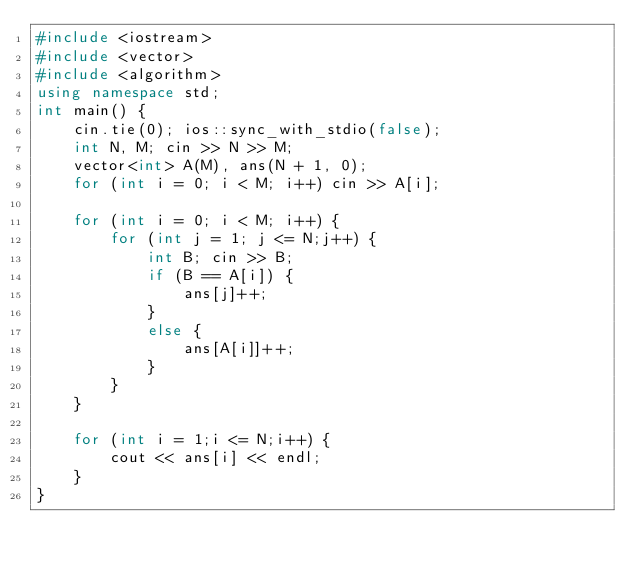<code> <loc_0><loc_0><loc_500><loc_500><_C++_>#include <iostream>
#include <vector>
#include <algorithm>
using namespace std;
int main() {
	cin.tie(0); ios::sync_with_stdio(false);
	int N, M; cin >> N >> M;
	vector<int> A(M), ans(N + 1, 0);
	for (int i = 0; i < M; i++) cin >> A[i];
	
	for (int i = 0; i < M; i++) {
		for (int j = 1; j <= N;j++) {
			int B; cin >> B;
			if (B == A[i]) {
				ans[j]++;
			}
			else {
				ans[A[i]]++;
			}
		}
	}

	for (int i = 1;i <= N;i++) {
		cout << ans[i] << endl;
	}
}</code> 